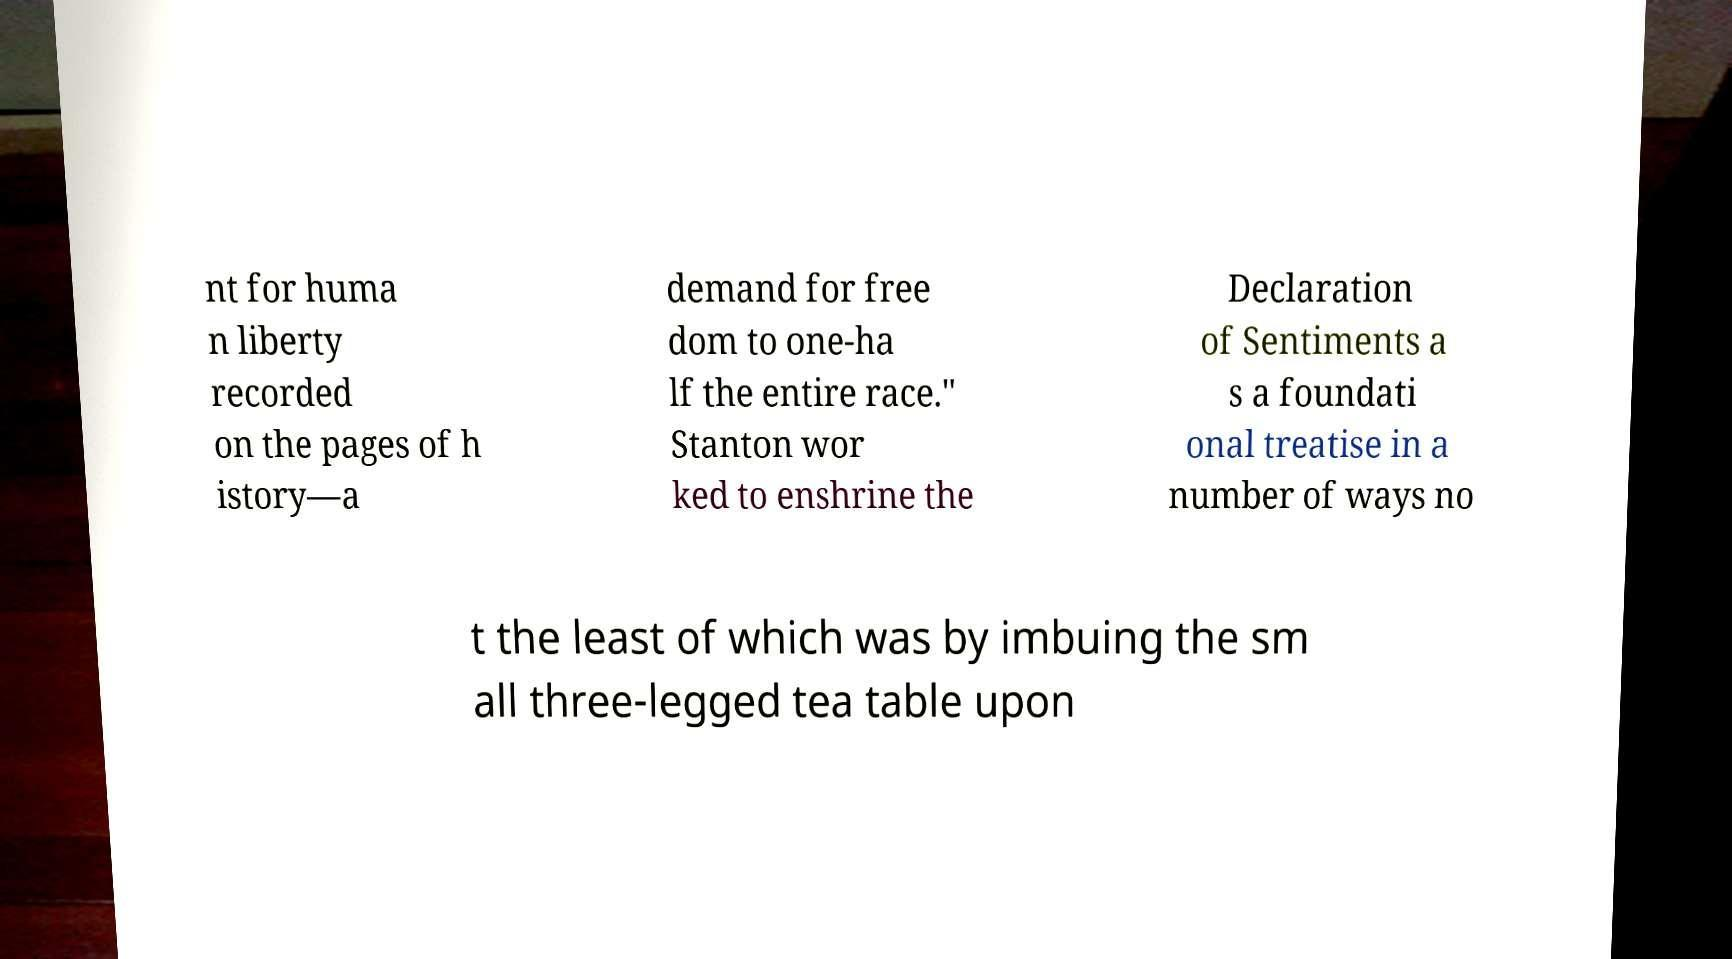What messages or text are displayed in this image? I need them in a readable, typed format. nt for huma n liberty recorded on the pages of h istory—a demand for free dom to one-ha lf the entire race." Stanton wor ked to enshrine the Declaration of Sentiments a s a foundati onal treatise in a number of ways no t the least of which was by imbuing the sm all three-legged tea table upon 